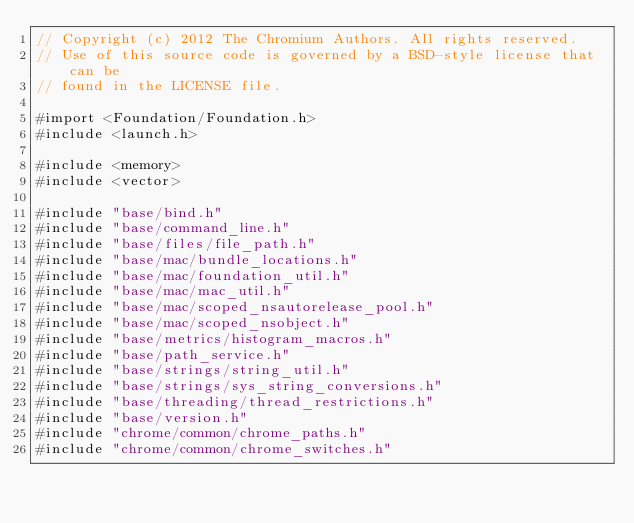<code> <loc_0><loc_0><loc_500><loc_500><_ObjectiveC_>// Copyright (c) 2012 The Chromium Authors. All rights reserved.
// Use of this source code is governed by a BSD-style license that can be
// found in the LICENSE file.

#import <Foundation/Foundation.h>
#include <launch.h>

#include <memory>
#include <vector>

#include "base/bind.h"
#include "base/command_line.h"
#include "base/files/file_path.h"
#include "base/mac/bundle_locations.h"
#include "base/mac/foundation_util.h"
#include "base/mac/mac_util.h"
#include "base/mac/scoped_nsautorelease_pool.h"
#include "base/mac/scoped_nsobject.h"
#include "base/metrics/histogram_macros.h"
#include "base/path_service.h"
#include "base/strings/string_util.h"
#include "base/strings/sys_string_conversions.h"
#include "base/threading/thread_restrictions.h"
#include "base/version.h"
#include "chrome/common/chrome_paths.h"
#include "chrome/common/chrome_switches.h"</code> 